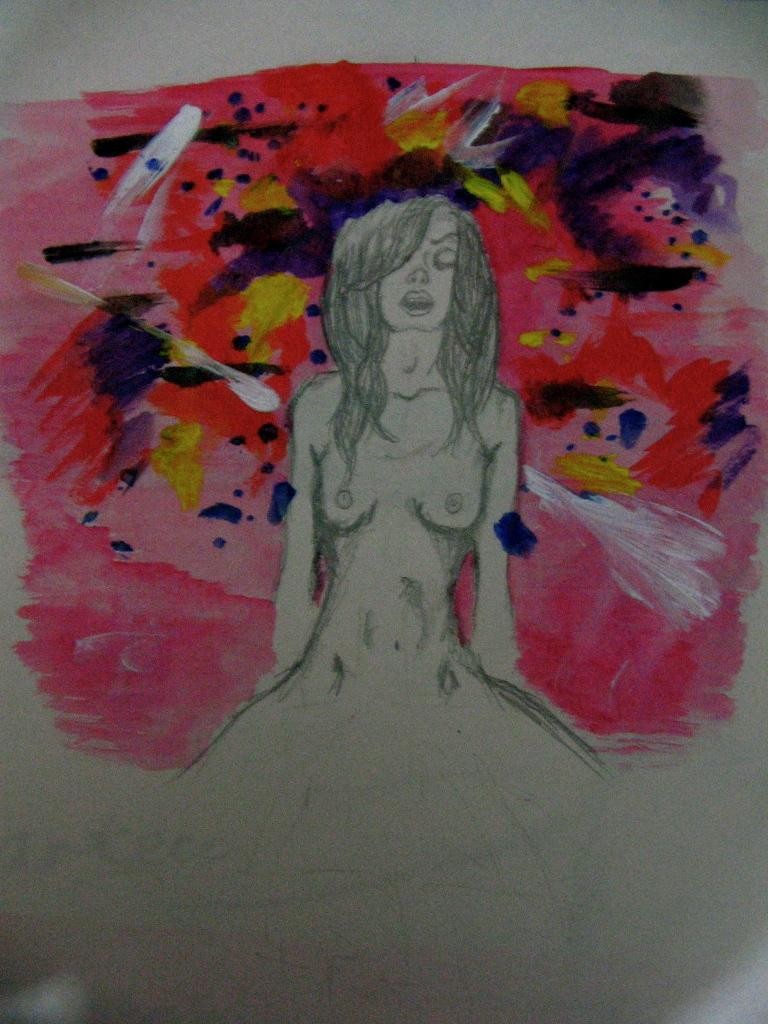What is depicted in the image? There is a drawing of a woman in the image. What can be inferred about the medium used for the drawing? The drawing is on a surface, which suggests it might be on paper, canvas, or another drawing material. What type of linen is used to create the drawing in the image? There is no mention of linen being used in the image, as the drawing is likely on paper or another drawing surface. What flavor of eggnog is being served in the image? There is no reference to eggnog or any food or drink in the image; it only features a drawing of a woman. 